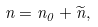Convert formula to latex. <formula><loc_0><loc_0><loc_500><loc_500>n = n _ { 0 } + \widetilde { n } ,</formula> 